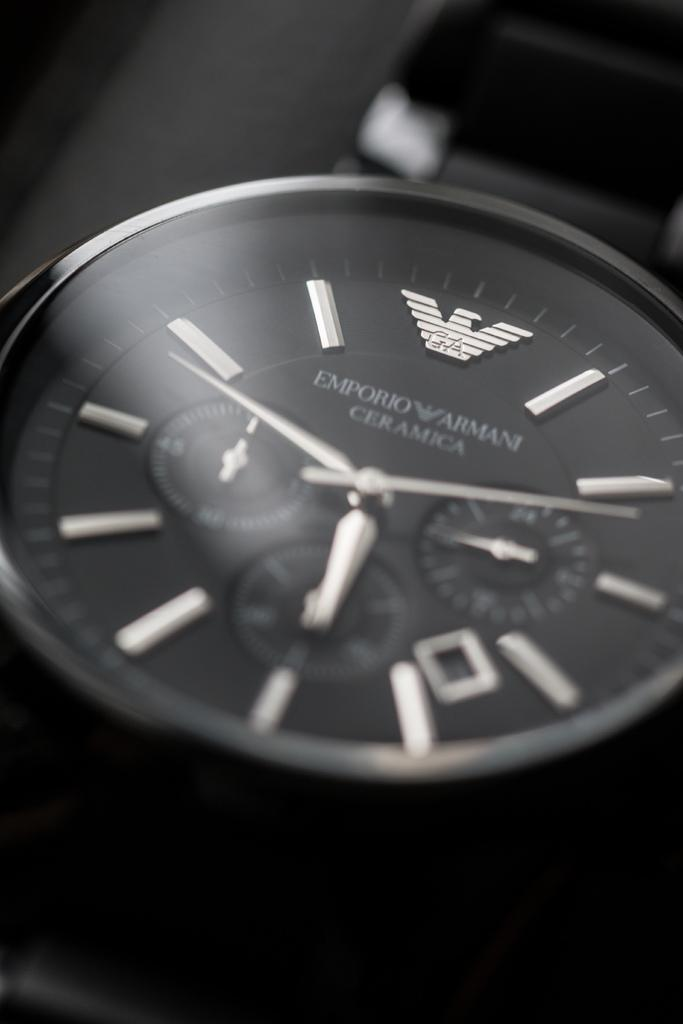<image>
Provide a brief description of the given image. An Emporio Armani watch has a black face and silver hands. 